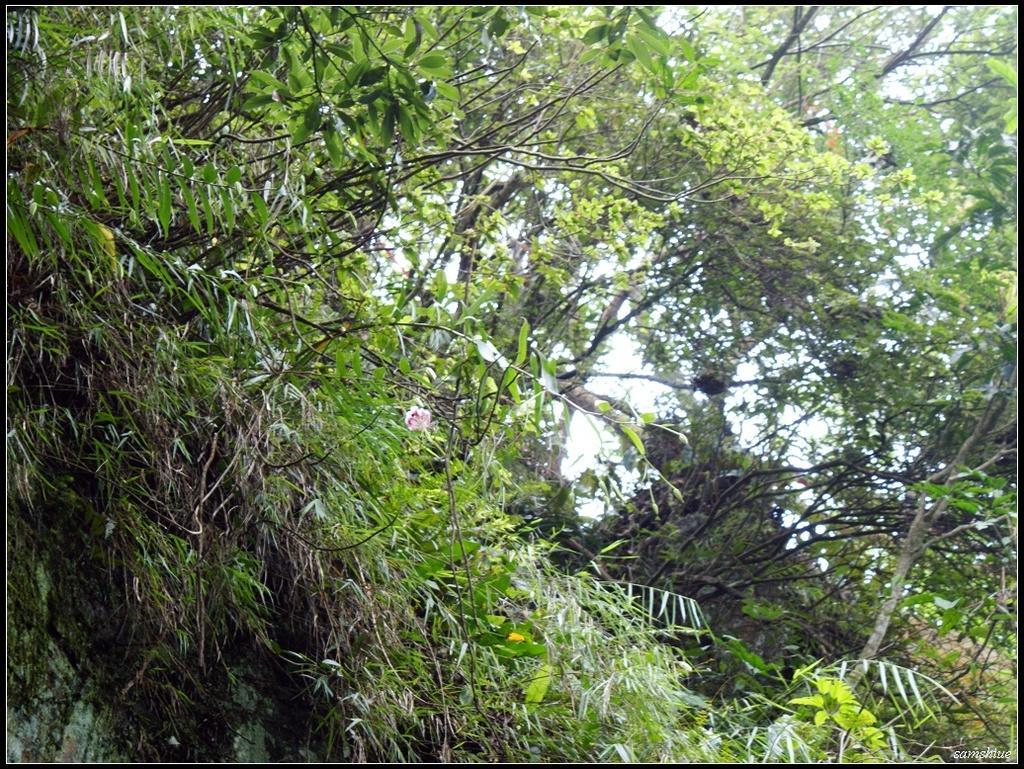Please provide a concise description of this image. In the image there are many branches of different trees. In the background there is a sky. 